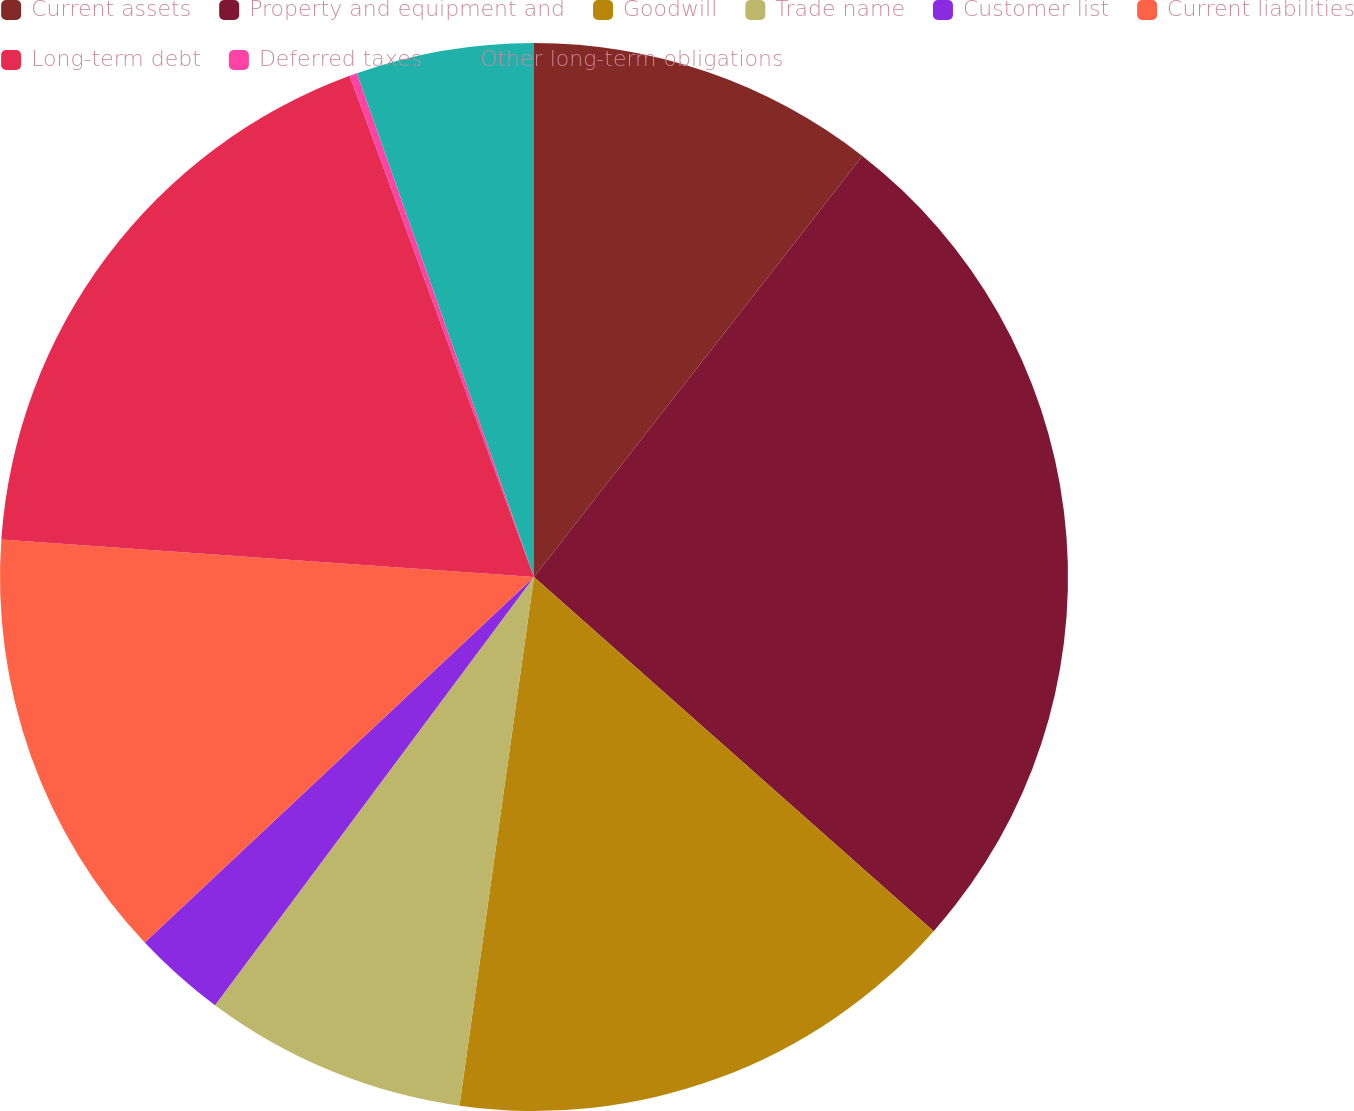Convert chart. <chart><loc_0><loc_0><loc_500><loc_500><pie_chart><fcel>Current assets<fcel>Property and equipment and<fcel>Goodwill<fcel>Trade name<fcel>Customer list<fcel>Current liabilities<fcel>Long-term debt<fcel>Deferred taxes<fcel>Other long-term obligations<nl><fcel>10.54%<fcel>26.0%<fcel>15.69%<fcel>7.96%<fcel>2.81%<fcel>13.12%<fcel>18.27%<fcel>0.23%<fcel>5.38%<nl></chart> 